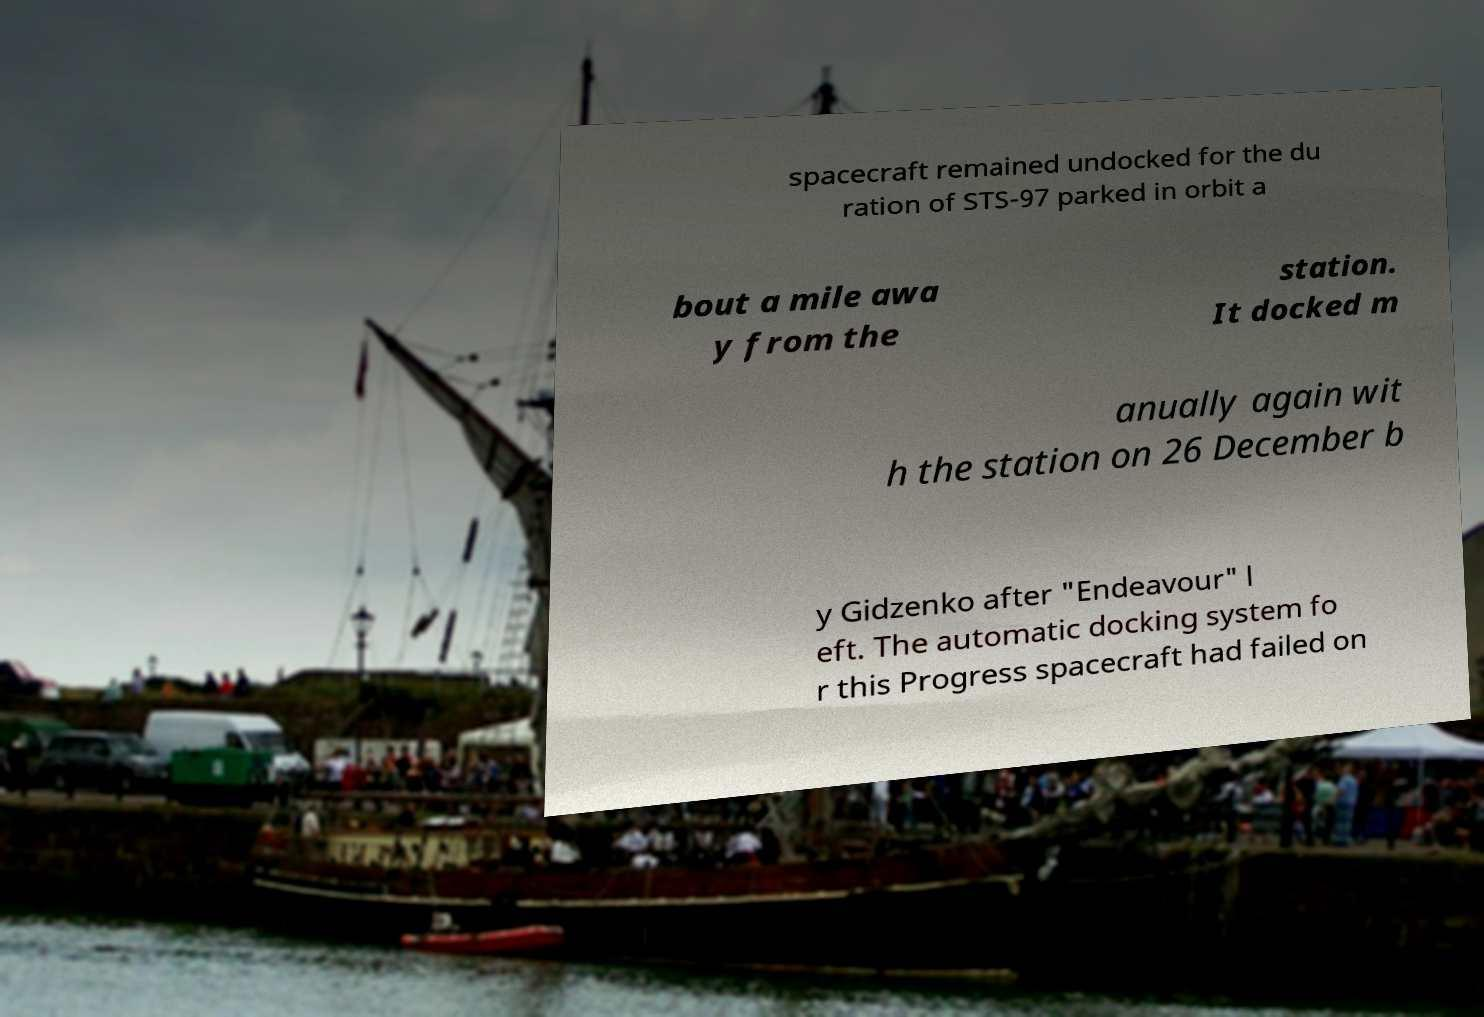For documentation purposes, I need the text within this image transcribed. Could you provide that? spacecraft remained undocked for the du ration of STS-97 parked in orbit a bout a mile awa y from the station. It docked m anually again wit h the station on 26 December b y Gidzenko after "Endeavour" l eft. The automatic docking system fo r this Progress spacecraft had failed on 